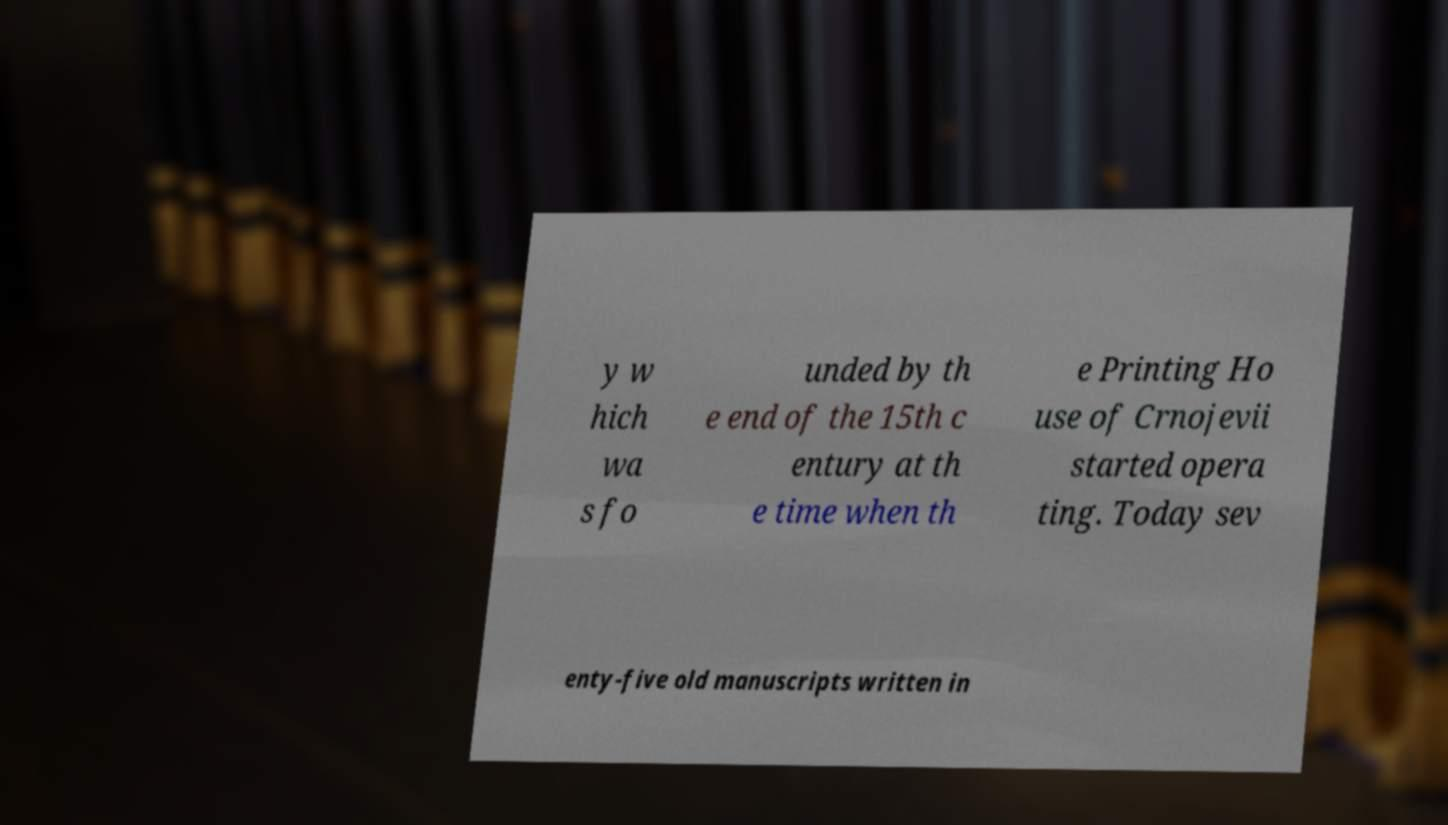There's text embedded in this image that I need extracted. Can you transcribe it verbatim? y w hich wa s fo unded by th e end of the 15th c entury at th e time when th e Printing Ho use of Crnojevii started opera ting. Today sev enty-five old manuscripts written in 